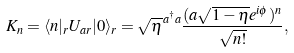<formula> <loc_0><loc_0><loc_500><loc_500>K _ { n } = \langle n | _ { r } U _ { a r } | 0 \rangle _ { r } = \sqrt { \eta } ^ { a ^ { \dag } a } \frac { ( a \sqrt { 1 - \eta } e ^ { i \phi } ) ^ { n } } { \sqrt { n ! } } ,</formula> 